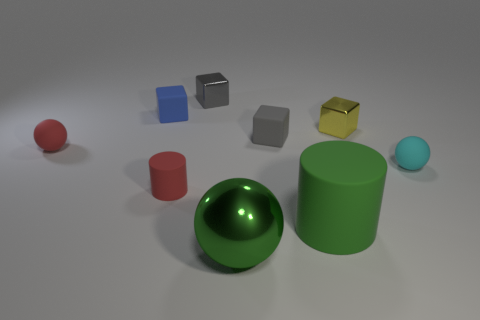Are there any other things that are the same color as the large cylinder?
Keep it short and to the point. Yes. What number of green objects are rubber cubes or small rubber things?
Give a very brief answer. 0. Is the number of blue rubber things greater than the number of blocks?
Ensure brevity in your answer.  No. Does the ball that is on the right side of the large green ball have the same size as the red matte object that is in front of the small cyan thing?
Provide a short and direct response. Yes. There is a tiny sphere that is in front of the rubber sphere that is on the left side of the small gray thing that is behind the blue matte object; what color is it?
Provide a short and direct response. Cyan. Are there any small metallic things of the same shape as the blue matte thing?
Your answer should be very brief. Yes. Are there more tiny metal cubes that are right of the red ball than cyan objects?
Ensure brevity in your answer.  Yes. What number of matte things are either green cubes or cylinders?
Your response must be concise. 2. There is a cube that is on the left side of the yellow object and on the right side of the green metal thing; what size is it?
Keep it short and to the point. Small. There is a big object behind the big metallic thing; is there a tiny matte thing on the right side of it?
Keep it short and to the point. Yes. 